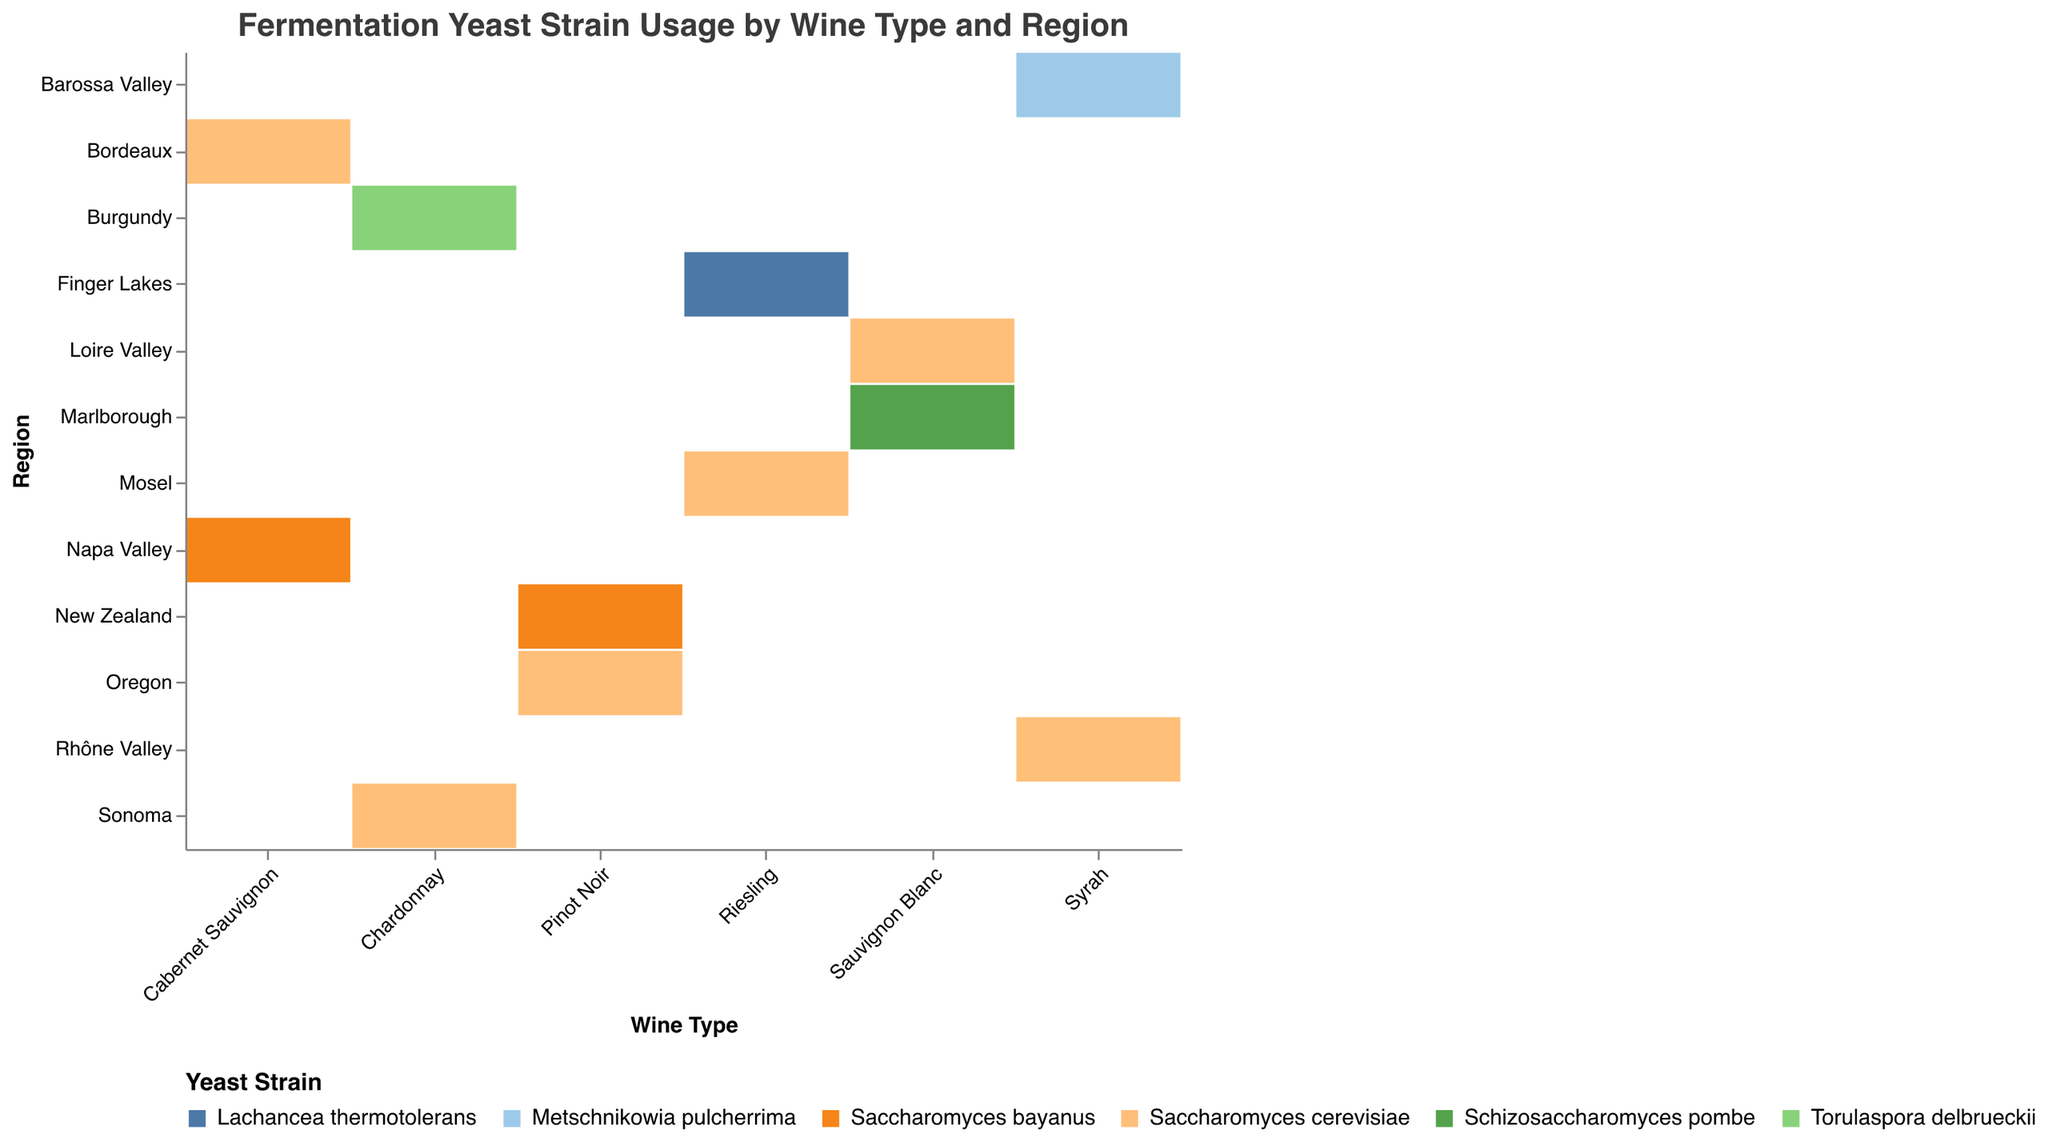What is the wine type with the highest count of Saccharomyces cerevisiae usage? The plot shows the count of each yeast strain usage by wine type and region. Look for the largest area of rectangles corresponding to Saccharomyces cerevisiae and identify the wine type.
Answer: Cabernet Sauvignon How many yeast strains are used in the Napa Valley region? In the mosaic plot, find the Napa Valley region on the y-axis and count the different yeast strains represented by colors within that region.
Answer: 1 Which region has the highest count of Torulaspora delbrueckii usage? Locate the areas representing Torulaspora delbrueckii. Compare their sizes across different regions.
Answer: Burgundy In which region and wine type is Schizosaccharomyces pombe used? Look at the plot for the Schizosaccharomyces pombe color and identify its corresponding region and wine type.
Answer: Marlborough, Sauvignon Blanc Comparing Sacramento cerevisiae, which wine type has the smallest count? Find all the rectangles labeled with Saccharomyces cerevisiae and look for the smallest one. Note its corresponding wine type.
Answer: Pinot Noir What is the total count of Riesling wines from both regions combined? Add the count values for Riesling wines from both regions, i.e., Mosel and Finger Lakes.
Answer: 57 Which wine type has the greatest diversity in yeast strains used? Check the x-axis labels for each wine type and count the number of different yeast strains (colors) associated with each type.
Answer: Sauvignon Blanc Which yeast strain is used exclusively in one region for only one wine type? Look for unique colors (yeast strains) that appear in only one region and one wine type on the plot.
Answer: Lachancea thermotolerans Between Bordeaux and Napa Valley, which region uses a higher total count of yeast strains for Cabernet Sauvignon? Sum the count values of each yeast strain for Cabernet Sauvignon in Bordeaux and Napa Valley, then compare.
Answer: Bordeaux Does Pinot Noir from Oregon or New Zealand have a higher count of Saccharomyces bayanus? Identify the counts for Saccharomyces bayanus in Pinot Noir from both Oregon and New Zealand, and compare them.
Answer: New Zealand 